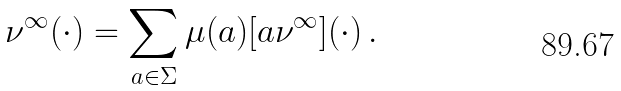Convert formula to latex. <formula><loc_0><loc_0><loc_500><loc_500>\nu ^ { \infty } ( \cdot ) = \sum _ { a \in \Sigma } \mu ( a ) [ a \nu ^ { \infty } ] ( \cdot ) \, .</formula> 